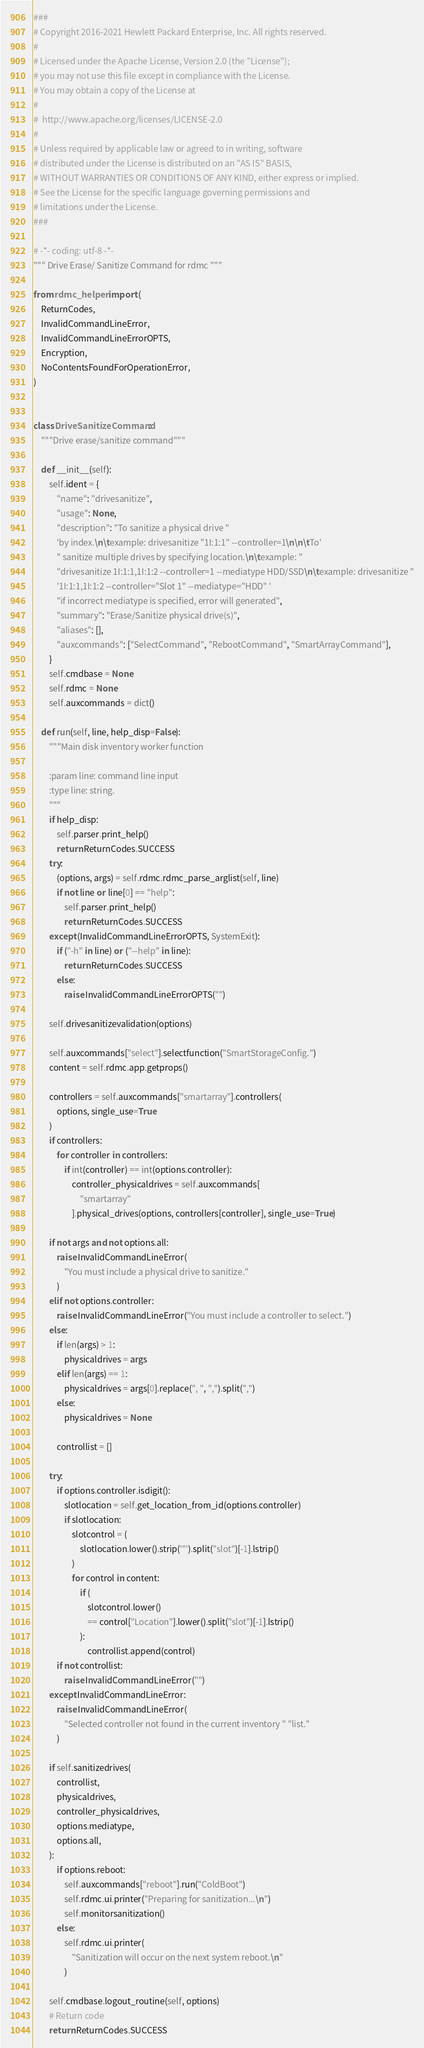<code> <loc_0><loc_0><loc_500><loc_500><_Python_>###
# Copyright 2016-2021 Hewlett Packard Enterprise, Inc. All rights reserved.
#
# Licensed under the Apache License, Version 2.0 (the "License");
# you may not use this file except in compliance with the License.
# You may obtain a copy of the License at
#
#  http://www.apache.org/licenses/LICENSE-2.0
#
# Unless required by applicable law or agreed to in writing, software
# distributed under the License is distributed on an "AS IS" BASIS,
# WITHOUT WARRANTIES OR CONDITIONS OF ANY KIND, either express or implied.
# See the License for the specific language governing permissions and
# limitations under the License.
###

# -*- coding: utf-8 -*-
""" Drive Erase/ Sanitize Command for rdmc """

from rdmc_helper import (
    ReturnCodes,
    InvalidCommandLineError,
    InvalidCommandLineErrorOPTS,
    Encryption,
    NoContentsFoundForOperationError,
)


class DriveSanitizeCommand:
    """Drive erase/sanitize command"""

    def __init__(self):
        self.ident = {
            "name": "drivesanitize",
            "usage": None,
            "description": "To sanitize a physical drive "
            'by index.\n\texample: drivesanitize "1I:1:1" --controller=1\n\n\tTo'
            " sanitize multiple drives by specifying location.\n\texample: "
            "drivesanitize 1I:1:1,1I:1:2 --controller=1 --mediatype HDD/SSD\n\texample: drivesanitize "
            '1I:1:1,1I:1:2 --controller="Slot 1" --mediatype="HDD" '
            "if incorrect mediatype is specified, error will generated",
            "summary": "Erase/Sanitize physical drive(s)",
            "aliases": [],
            "auxcommands": ["SelectCommand", "RebootCommand", "SmartArrayCommand"],
        }
        self.cmdbase = None
        self.rdmc = None
        self.auxcommands = dict()

    def run(self, line, help_disp=False):
        """Main disk inventory worker function

        :param line: command line input
        :type line: string.
        """
        if help_disp:
            self.parser.print_help()
            return ReturnCodes.SUCCESS
        try:
            (options, args) = self.rdmc.rdmc_parse_arglist(self, line)
            if not line or line[0] == "help":
                self.parser.print_help()
                return ReturnCodes.SUCCESS
        except (InvalidCommandLineErrorOPTS, SystemExit):
            if ("-h" in line) or ("--help" in line):
                return ReturnCodes.SUCCESS
            else:
                raise InvalidCommandLineErrorOPTS("")

        self.drivesanitizevalidation(options)

        self.auxcommands["select"].selectfunction("SmartStorageConfig.")
        content = self.rdmc.app.getprops()

        controllers = self.auxcommands["smartarray"].controllers(
            options, single_use=True
        )
        if controllers:
            for controller in controllers:
                if int(controller) == int(options.controller):
                    controller_physicaldrives = self.auxcommands[
                        "smartarray"
                    ].physical_drives(options, controllers[controller], single_use=True)

        if not args and not options.all:
            raise InvalidCommandLineError(
                "You must include a physical drive to sanitize."
            )
        elif not options.controller:
            raise InvalidCommandLineError("You must include a controller to select.")
        else:
            if len(args) > 1:
                physicaldrives = args
            elif len(args) == 1:
                physicaldrives = args[0].replace(", ", ",").split(",")
            else:
                physicaldrives = None

            controllist = []

        try:
            if options.controller.isdigit():
                slotlocation = self.get_location_from_id(options.controller)
                if slotlocation:
                    slotcontrol = (
                        slotlocation.lower().strip('"').split("slot")[-1].lstrip()
                    )
                    for control in content:
                        if (
                            slotcontrol.lower()
                            == control["Location"].lower().split("slot")[-1].lstrip()
                        ):
                            controllist.append(control)
            if not controllist:
                raise InvalidCommandLineError("")
        except InvalidCommandLineError:
            raise InvalidCommandLineError(
                "Selected controller not found in the current inventory " "list."
            )

        if self.sanitizedrives(
            controllist,
            physicaldrives,
            controller_physicaldrives,
            options.mediatype,
            options.all,
        ):
            if options.reboot:
                self.auxcommands["reboot"].run("ColdBoot")
                self.rdmc.ui.printer("Preparing for sanitization...\n")
                self.monitorsanitization()
            else:
                self.rdmc.ui.printer(
                    "Sanitization will occur on the next system reboot.\n"
                )

        self.cmdbase.logout_routine(self, options)
        # Return code
        return ReturnCodes.SUCCESS
</code> 